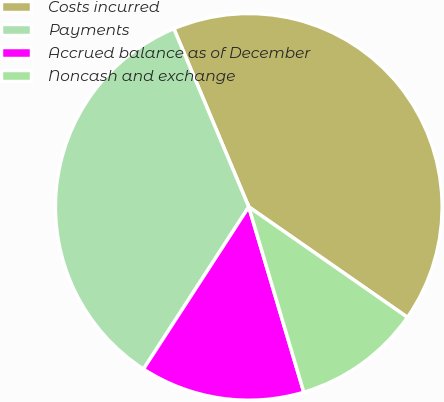Convert chart to OTSL. <chart><loc_0><loc_0><loc_500><loc_500><pie_chart><fcel>Costs incurred<fcel>Payments<fcel>Accrued balance as of December<fcel>Noncash and exchange<nl><fcel>41.01%<fcel>34.5%<fcel>13.76%<fcel>10.73%<nl></chart> 